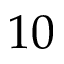Convert formula to latex. <formula><loc_0><loc_0><loc_500><loc_500>1 0</formula> 